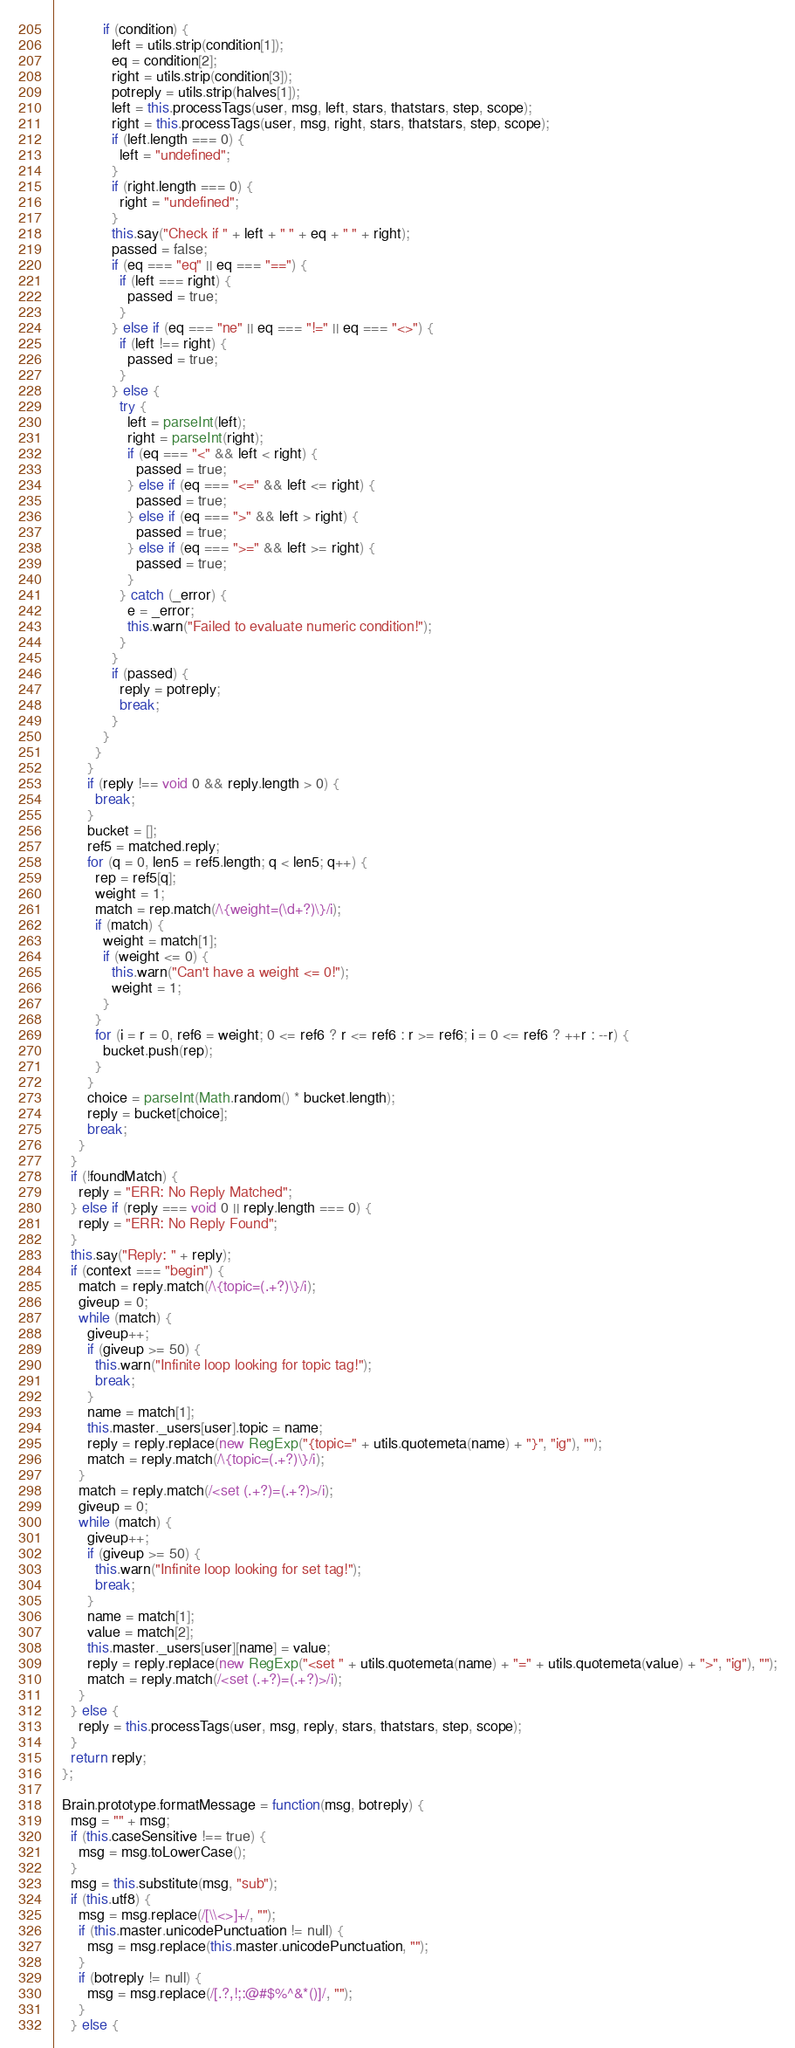<code> <loc_0><loc_0><loc_500><loc_500><_JavaScript_>            if (condition) {
              left = utils.strip(condition[1]);
              eq = condition[2];
              right = utils.strip(condition[3]);
              potreply = utils.strip(halves[1]);
              left = this.processTags(user, msg, left, stars, thatstars, step, scope);
              right = this.processTags(user, msg, right, stars, thatstars, step, scope);
              if (left.length === 0) {
                left = "undefined";
              }
              if (right.length === 0) {
                right = "undefined";
              }
              this.say("Check if " + left + " " + eq + " " + right);
              passed = false;
              if (eq === "eq" || eq === "==") {
                if (left === right) {
                  passed = true;
                }
              } else if (eq === "ne" || eq === "!=" || eq === "<>") {
                if (left !== right) {
                  passed = true;
                }
              } else {
                try {
                  left = parseInt(left);
                  right = parseInt(right);
                  if (eq === "<" && left < right) {
                    passed = true;
                  } else if (eq === "<=" && left <= right) {
                    passed = true;
                  } else if (eq === ">" && left > right) {
                    passed = true;
                  } else if (eq === ">=" && left >= right) {
                    passed = true;
                  }
                } catch (_error) {
                  e = _error;
                  this.warn("Failed to evaluate numeric condition!");
                }
              }
              if (passed) {
                reply = potreply;
                break;
              }
            }
          }
        }
        if (reply !== void 0 && reply.length > 0) {
          break;
        }
        bucket = [];
        ref5 = matched.reply;
        for (q = 0, len5 = ref5.length; q < len5; q++) {
          rep = ref5[q];
          weight = 1;
          match = rep.match(/\{weight=(\d+?)\}/i);
          if (match) {
            weight = match[1];
            if (weight <= 0) {
              this.warn("Can't have a weight <= 0!");
              weight = 1;
            }
          }
          for (i = r = 0, ref6 = weight; 0 <= ref6 ? r <= ref6 : r >= ref6; i = 0 <= ref6 ? ++r : --r) {
            bucket.push(rep);
          }
        }
        choice = parseInt(Math.random() * bucket.length);
        reply = bucket[choice];
        break;
      }
    }
    if (!foundMatch) {
      reply = "ERR: No Reply Matched";
    } else if (reply === void 0 || reply.length === 0) {
      reply = "ERR: No Reply Found";
    }
    this.say("Reply: " + reply);
    if (context === "begin") {
      match = reply.match(/\{topic=(.+?)\}/i);
      giveup = 0;
      while (match) {
        giveup++;
        if (giveup >= 50) {
          this.warn("Infinite loop looking for topic tag!");
          break;
        }
        name = match[1];
        this.master._users[user].topic = name;
        reply = reply.replace(new RegExp("{topic=" + utils.quotemeta(name) + "}", "ig"), "");
        match = reply.match(/\{topic=(.+?)\}/i);
      }
      match = reply.match(/<set (.+?)=(.+?)>/i);
      giveup = 0;
      while (match) {
        giveup++;
        if (giveup >= 50) {
          this.warn("Infinite loop looking for set tag!");
          break;
        }
        name = match[1];
        value = match[2];
        this.master._users[user][name] = value;
        reply = reply.replace(new RegExp("<set " + utils.quotemeta(name) + "=" + utils.quotemeta(value) + ">", "ig"), "");
        match = reply.match(/<set (.+?)=(.+?)>/i);
      }
    } else {
      reply = this.processTags(user, msg, reply, stars, thatstars, step, scope);
    }
    return reply;
  };

  Brain.prototype.formatMessage = function(msg, botreply) {
    msg = "" + msg;
    if (this.caseSensitive !== true) {
      msg = msg.toLowerCase();
    }
    msg = this.substitute(msg, "sub");
    if (this.utf8) {
      msg = msg.replace(/[\\<>]+/, "");
      if (this.master.unicodePunctuation != null) {
        msg = msg.replace(this.master.unicodePunctuation, "");
      }
      if (botreply != null) {
        msg = msg.replace(/[.?,!;:@#$%^&*()]/, "");
      }
    } else {</code> 